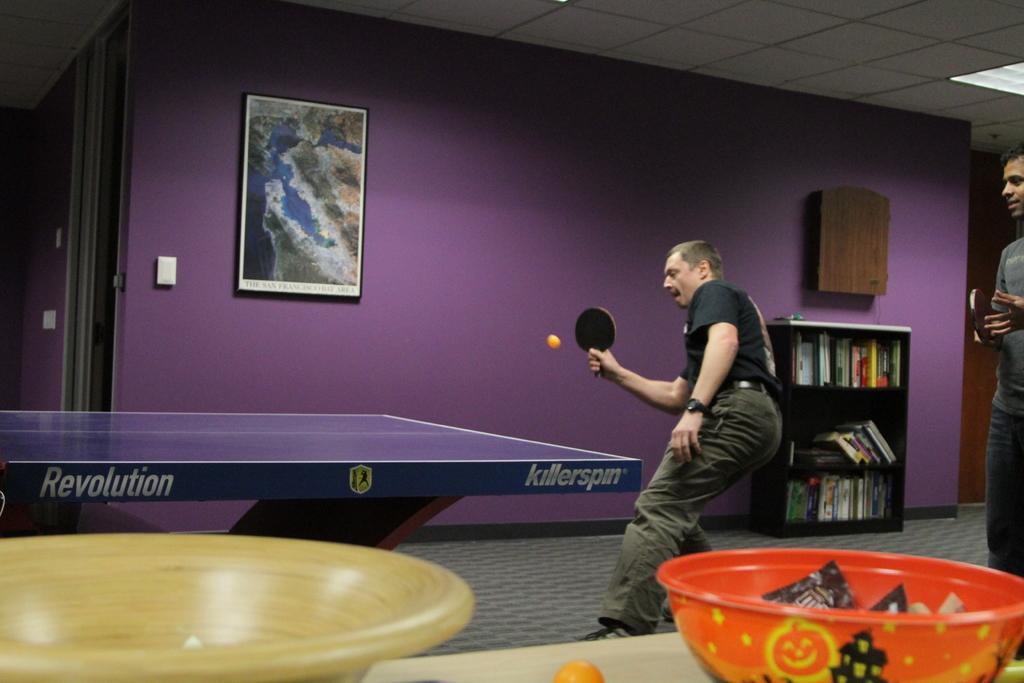Describe this image in one or two sentences. In the picture we find a man playing a table tennis holding a tennis racket in his hand. Behind to him there is another person. In the background we can find a wall and painting and cupboard with full of books. In the front we can find a table and bowl and few things in it. 